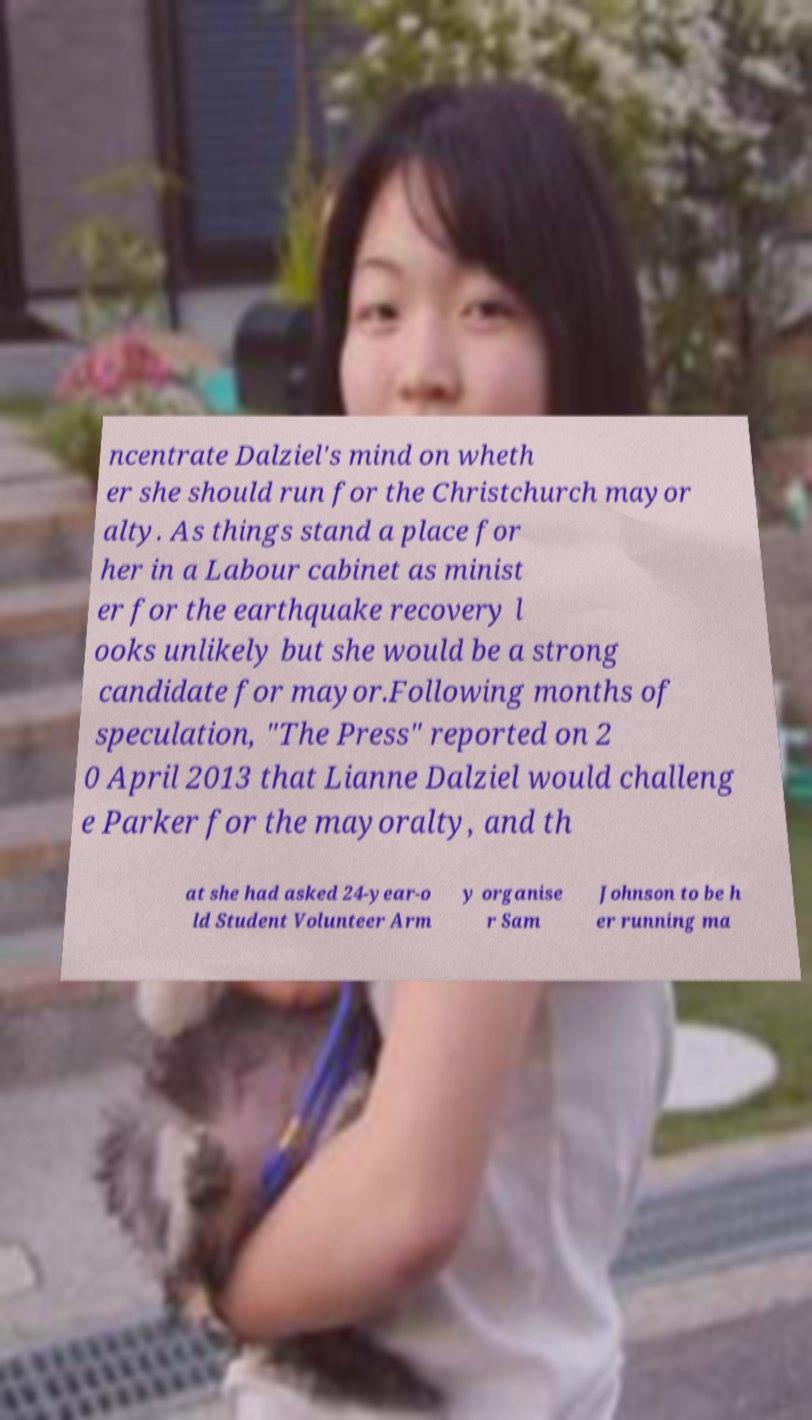What messages or text are displayed in this image? I need them in a readable, typed format. ncentrate Dalziel's mind on wheth er she should run for the Christchurch mayor alty. As things stand a place for her in a Labour cabinet as minist er for the earthquake recovery l ooks unlikely but she would be a strong candidate for mayor.Following months of speculation, "The Press" reported on 2 0 April 2013 that Lianne Dalziel would challeng e Parker for the mayoralty, and th at she had asked 24-year-o ld Student Volunteer Arm y organise r Sam Johnson to be h er running ma 